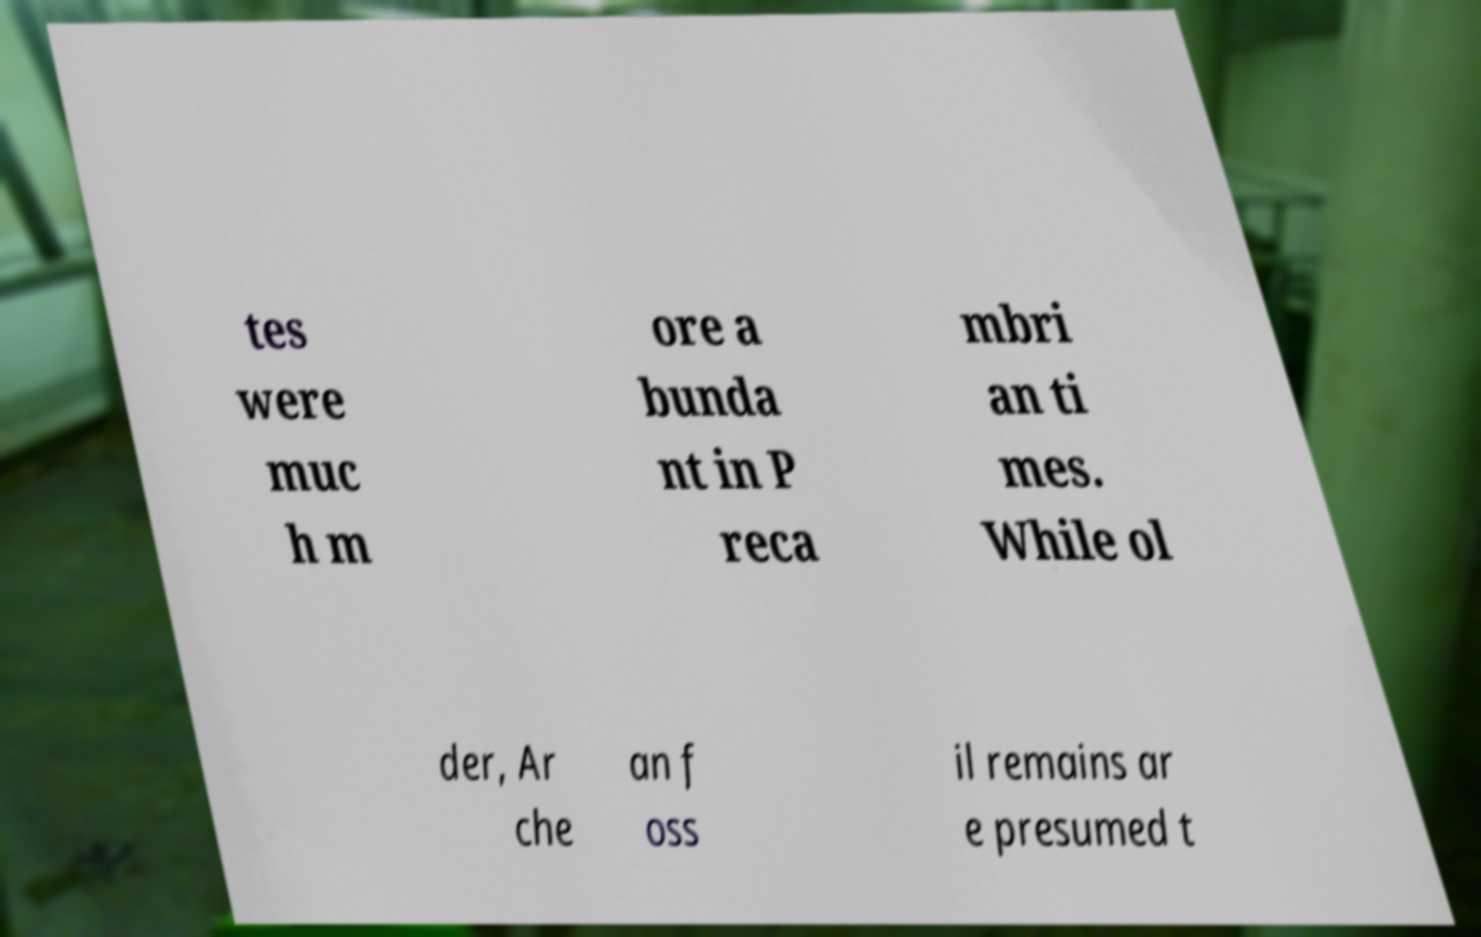Can you read and provide the text displayed in the image?This photo seems to have some interesting text. Can you extract and type it out for me? tes were muc h m ore a bunda nt in P reca mbri an ti mes. While ol der, Ar che an f oss il remains ar e presumed t 